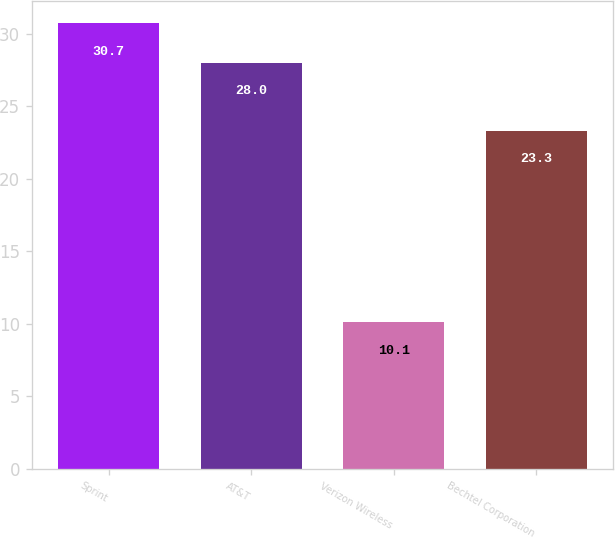Convert chart to OTSL. <chart><loc_0><loc_0><loc_500><loc_500><bar_chart><fcel>Sprint<fcel>AT&T<fcel>Verizon Wireless<fcel>Bechtel Corporation<nl><fcel>30.7<fcel>28<fcel>10.1<fcel>23.3<nl></chart> 